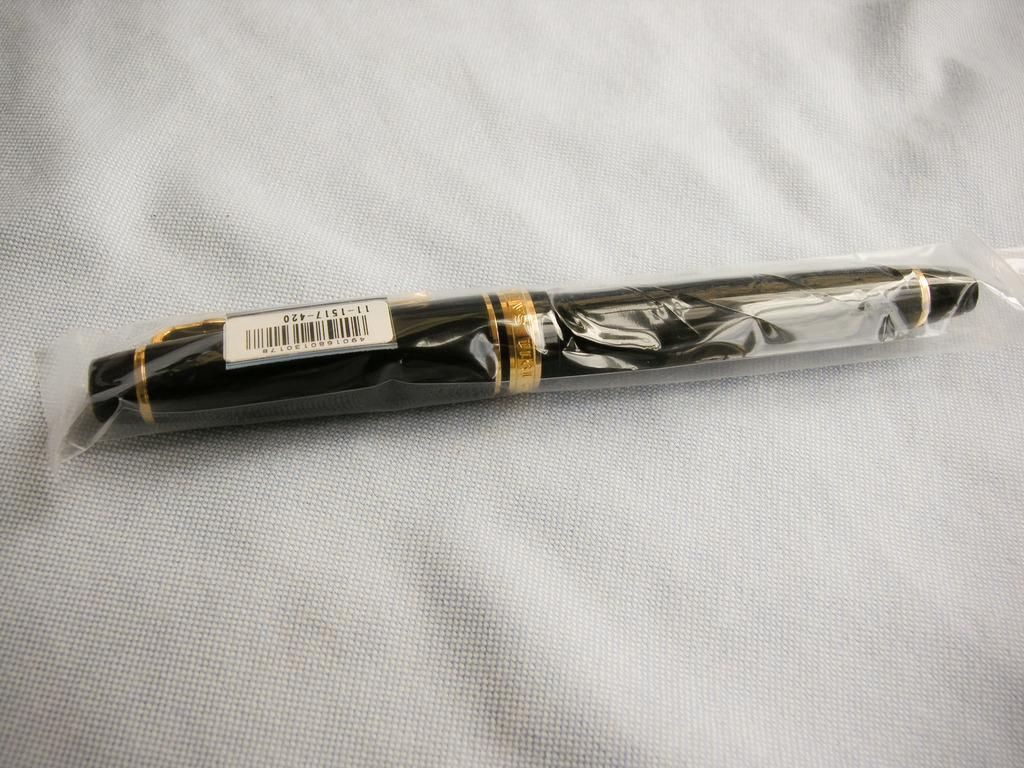Describe this image in one or two sentences. In the center of the image we can see pen placed on the cloth. 